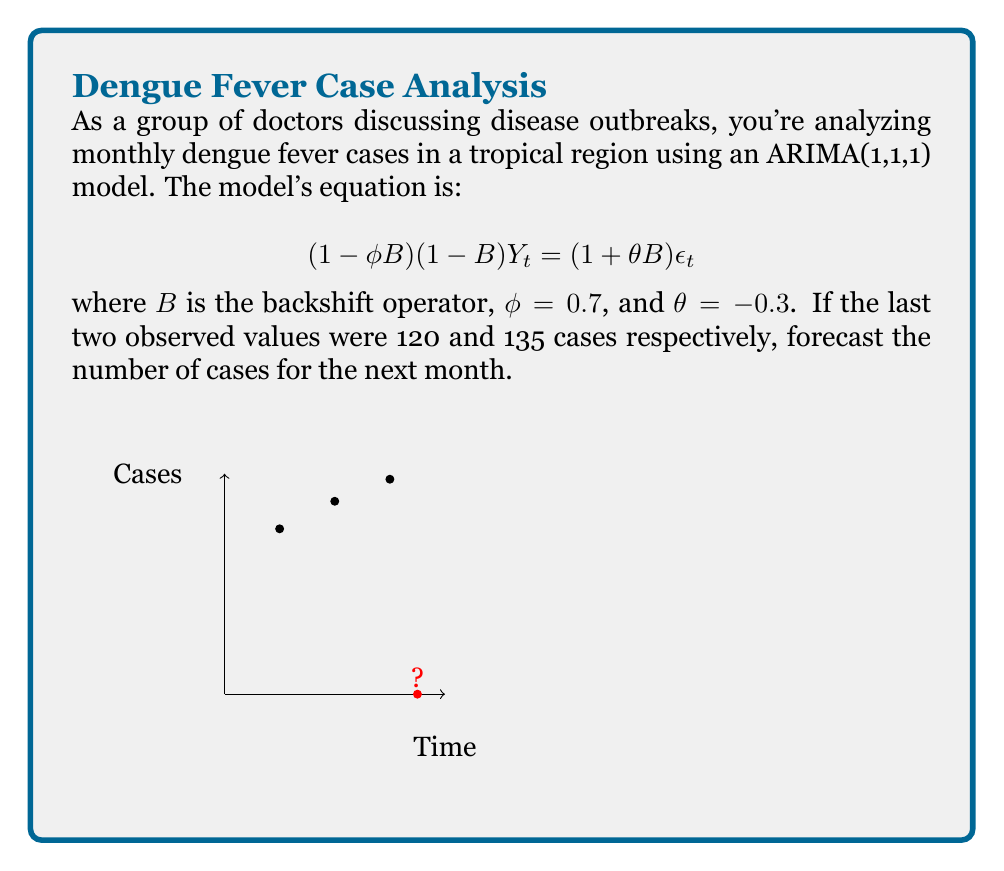Give your solution to this math problem. Let's approach this step-by-step:

1) The ARIMA(1,1,1) model can be expanded as:
   $$Y_t - Y_{t-1} = \phi(Y_{t-1} - Y_{t-2}) + \epsilon_t + \theta\epsilon_{t-1}$$

2) We need to forecast $Y_t$ given $Y_{t-1} = 135$ and $Y_{t-2} = 120$.

3) In the forecast equation, we set the error terms to their expected value, which is 0:
   $$Y_t - Y_{t-1} = \phi(Y_{t-1} - Y_{t-2})$$

4) Substituting the known values:
   $$Y_t - 135 = 0.7(135 - 120)$$

5) Simplify the right side:
   $$Y_t - 135 = 0.7(15) = 10.5$$

6) Solve for $Y_t$:
   $$Y_t = 135 + 10.5 = 145.5$$

7) Since we're dealing with whole numbers of cases, we round to the nearest integer:
   $$Y_t \approx 146$$

Therefore, the forecast for the next month is 146 dengue fever cases.
Answer: 146 cases 